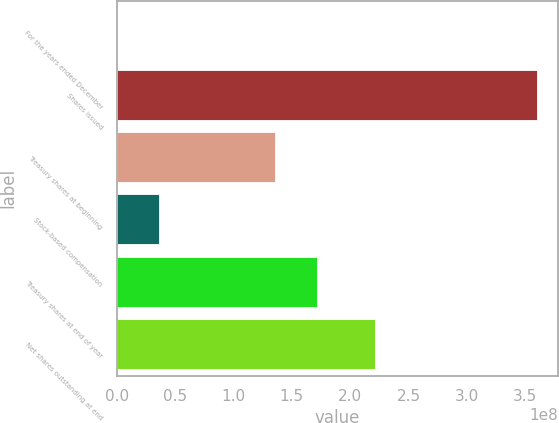Convert chart to OTSL. <chart><loc_0><loc_0><loc_500><loc_500><bar_chart><fcel>For the years ended December<fcel>Shares issued<fcel>Treasury shares at beginning<fcel>Stock-based compensation<fcel>Treasury shares at end of year<fcel>Net shares outstanding at end<nl><fcel>2014<fcel>3.59902e+08<fcel>1.36007e+08<fcel>3.5992e+07<fcel>1.71997e+08<fcel>2.21045e+08<nl></chart> 